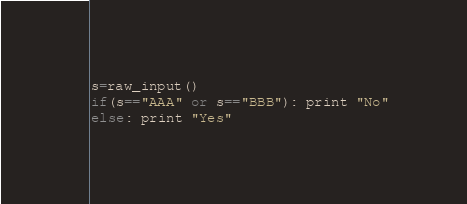Convert code to text. <code><loc_0><loc_0><loc_500><loc_500><_Python_>s=raw_input()
if(s=="AAA" or s=="BBB"): print "No"
else: print "Yes"</code> 